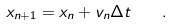<formula> <loc_0><loc_0><loc_500><loc_500>x _ { n + 1 } = x _ { n } + v _ { n } \Delta t \quad .</formula> 